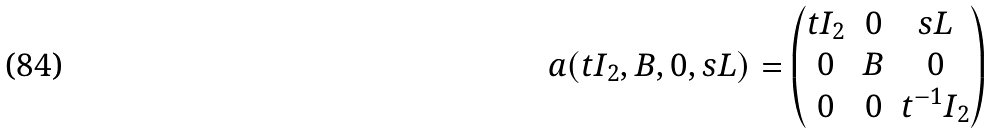Convert formula to latex. <formula><loc_0><loc_0><loc_500><loc_500>a ( t I _ { 2 } , B , 0 , s L ) = \begin{pmatrix} t I _ { 2 } & 0 & s L \\ 0 & B & 0 \\ 0 & 0 & t ^ { - 1 } I _ { 2 } \end{pmatrix}</formula> 